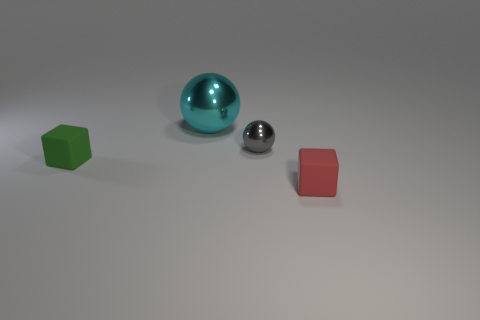Are there an equal number of big cyan things on the right side of the cyan thing and purple metal things?
Offer a terse response. Yes. Is there a tiny block in front of the rubber block to the left of the cube in front of the green cube?
Make the answer very short. Yes. Is the number of objects behind the tiny green matte object less than the number of things?
Ensure brevity in your answer.  Yes. How many other things are there of the same shape as the small green matte thing?
Make the answer very short. 1. How many things are either matte cubes that are left of the large sphere or small blocks behind the red rubber block?
Make the answer very short. 1. What size is the thing that is both on the left side of the tiny gray thing and on the right side of the tiny green thing?
Keep it short and to the point. Large. There is a matte object that is left of the gray metallic object; does it have the same shape as the red object?
Your answer should be compact. Yes. There is a block that is in front of the matte cube behind the cube that is right of the big metal object; how big is it?
Give a very brief answer. Small. How many objects are either small metal balls or cyan metallic things?
Offer a terse response. 2. There is a small object that is in front of the small gray ball and on the right side of the large metal object; what is its shape?
Provide a short and direct response. Cube. 